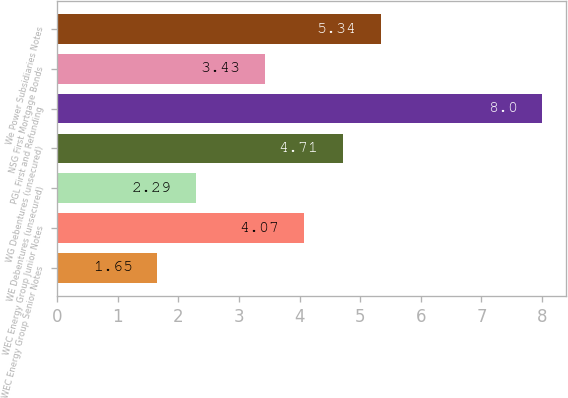Convert chart to OTSL. <chart><loc_0><loc_0><loc_500><loc_500><bar_chart><fcel>WEC Energy Group Senior Notes<fcel>WEC Energy Group Junior Notes<fcel>WE Debentures (unsecured)<fcel>WG Debentures (unsecured)<fcel>PGL First and Refunding<fcel>NSG First Mortgage Bonds<fcel>We Power Subsidiaries Notes<nl><fcel>1.65<fcel>4.07<fcel>2.29<fcel>4.71<fcel>8<fcel>3.43<fcel>5.34<nl></chart> 